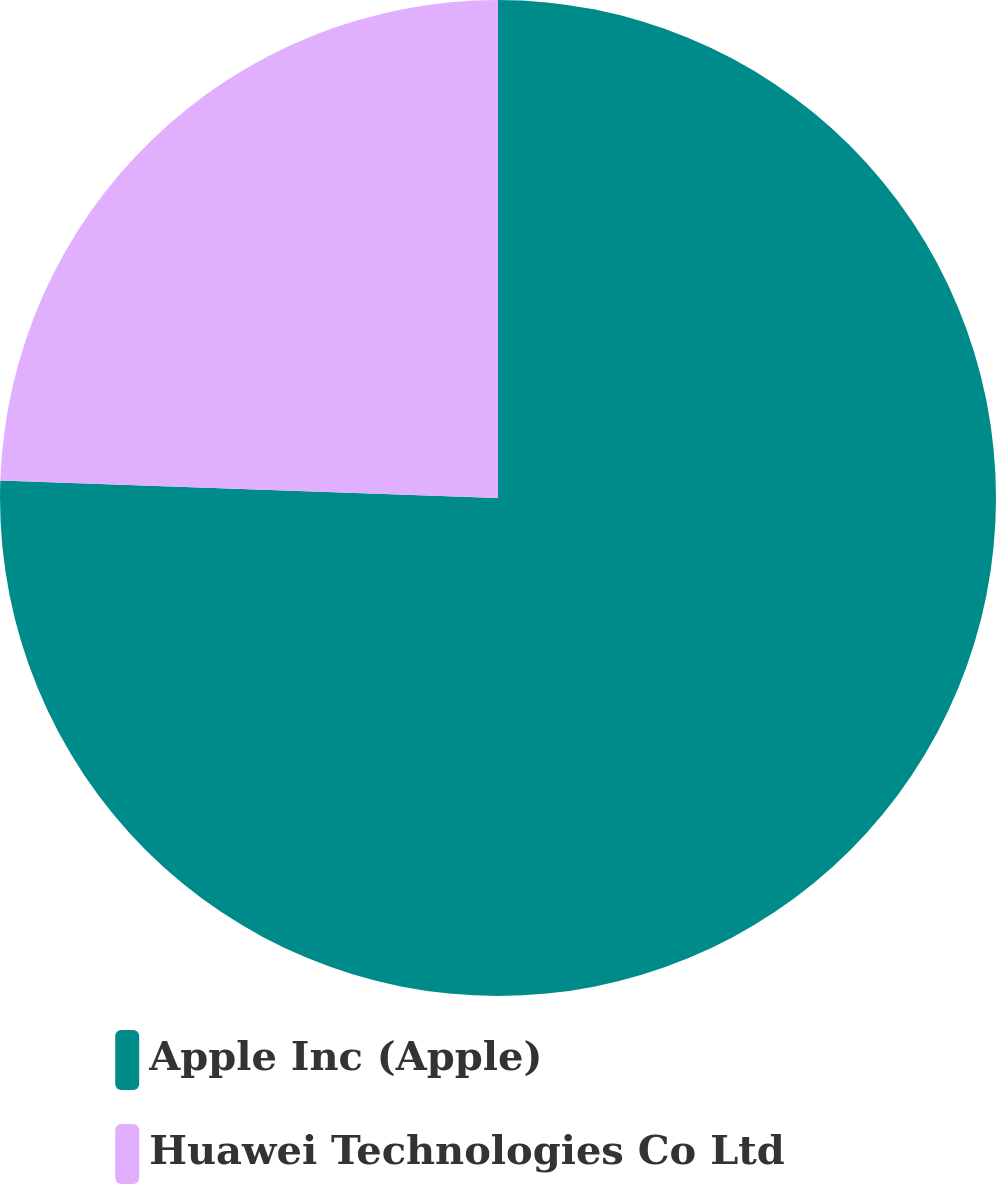Convert chart. <chart><loc_0><loc_0><loc_500><loc_500><pie_chart><fcel>Apple Inc (Apple)<fcel>Huawei Technologies Co Ltd<nl><fcel>75.56%<fcel>24.44%<nl></chart> 